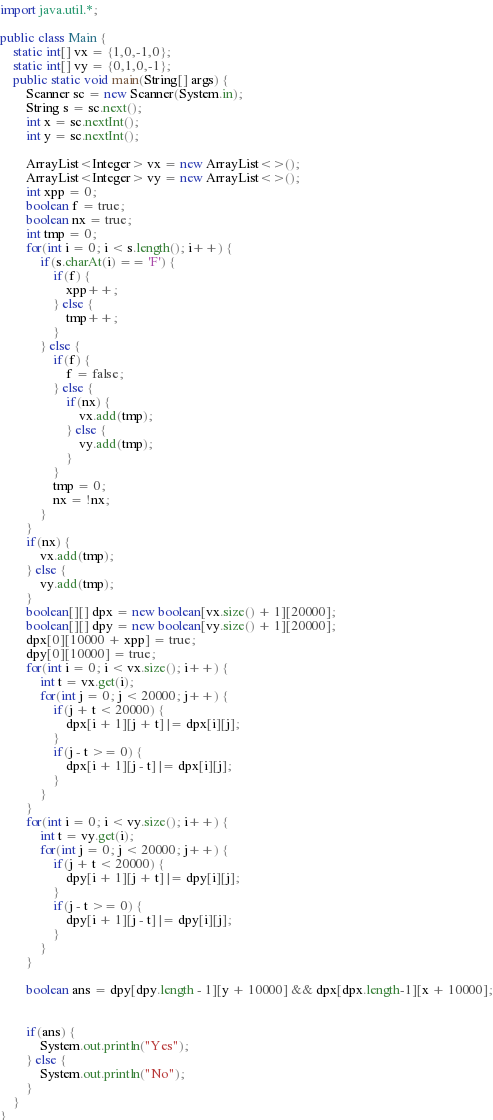Convert code to text. <code><loc_0><loc_0><loc_500><loc_500><_Java_>import java.util.*;

public class Main {
    static int[] vx = {1,0,-1,0};
    static int[] vy = {0,1,0,-1};
    public static void main(String[] args) {
        Scanner sc = new Scanner(System.in);
        String s = sc.next();
        int x = sc.nextInt();
        int y = sc.nextInt();

        ArrayList<Integer> vx = new ArrayList<>();
        ArrayList<Integer> vy = new ArrayList<>();
        int xpp = 0;
        boolean f = true;
        boolean nx = true;
        int tmp = 0;
        for(int i = 0; i < s.length(); i++) {
            if(s.charAt(i) == 'F') {
                if(f) {
                    xpp++;
                } else {
                    tmp++;
                }
            } else {
                if(f) {
                    f = false;
                } else {
                    if(nx) {
                        vx.add(tmp);
                    } else {
                        vy.add(tmp);
                    }
                }
                tmp = 0;
                nx = !nx;
            }
        }
        if(nx) {
            vx.add(tmp);
        } else {
            vy.add(tmp);
        }
        boolean[][] dpx = new boolean[vx.size() + 1][20000];
        boolean[][] dpy = new boolean[vy.size() + 1][20000];
        dpx[0][10000 + xpp] = true;
        dpy[0][10000] = true;
        for(int i = 0; i < vx.size(); i++) {
            int t = vx.get(i);
            for(int j = 0; j < 20000; j++) {
                if(j + t < 20000) {
                    dpx[i + 1][j + t] |= dpx[i][j];
                }
                if(j - t >= 0) {
                    dpx[i + 1][j - t] |= dpx[i][j];
                }
            }
        }
        for(int i = 0; i < vy.size(); i++) {
            int t = vy.get(i);
            for(int j = 0; j < 20000; j++) {
                if(j + t < 20000) {
                    dpy[i + 1][j + t] |= dpy[i][j];
                }
                if(j - t >= 0) {
                    dpy[i + 1][j - t] |= dpy[i][j];
                }
            }
        }

        boolean ans = dpy[dpy.length - 1][y + 10000] && dpx[dpx.length-1][x + 10000];


        if(ans) {
            System.out.println("Yes");
        } else {
            System.out.println("No");
        }
    }
}
</code> 